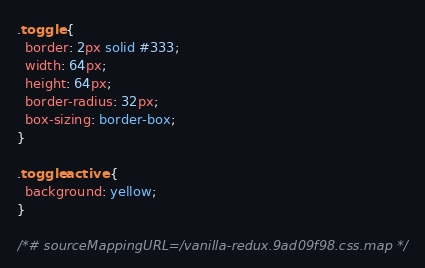Convert code to text. <code><loc_0><loc_0><loc_500><loc_500><_CSS_>.toggle {
  border: 2px solid #333;
  width: 64px;
  height: 64px;
  border-radius: 32px;
  box-sizing: border-box;
}

.toggle.active {
  background: yellow;
}

/*# sourceMappingURL=/vanilla-redux.9ad09f98.css.map */</code> 